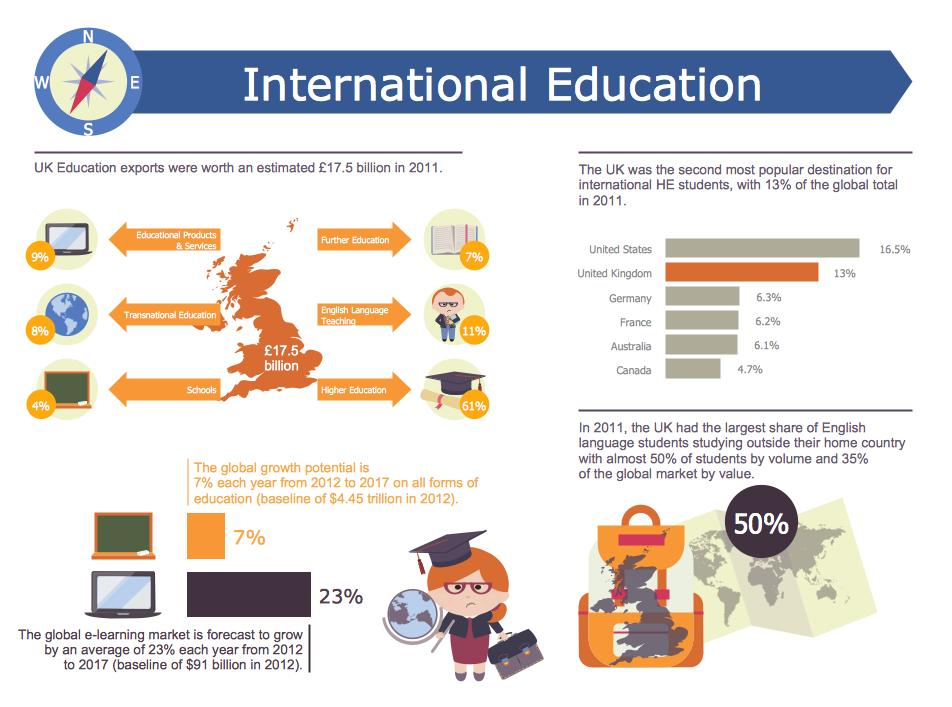Highlight a few significant elements in this photo. According to the data, France was the fourth most popular destination for education among international students. According to the given data, the total percentage of popular destinations for education is 52.8%. The e-learning market is projected to grow by $111 billion in 2013 if it grows at a rate of 23%. The predicted growth in global education in 2013, if the growth potential is 7%, is estimated to be $4.76 trillion. 